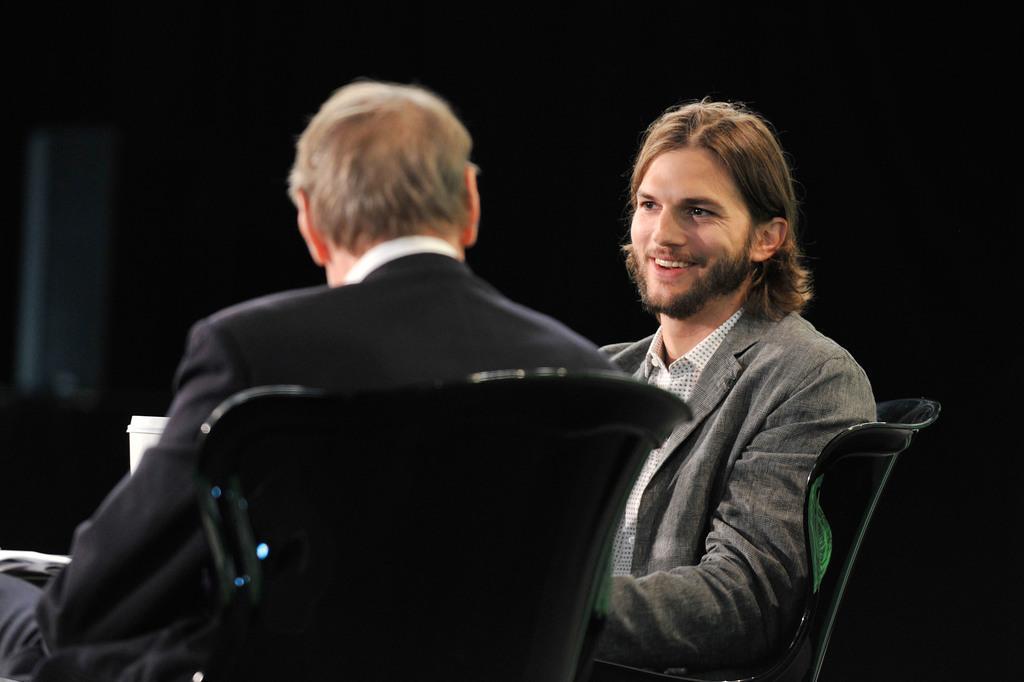How would you summarize this image in a sentence or two? In this image, I can see two persons are sitting on the chairs and one person is holding a paper in hand. In the background, I can see a dark color. This picture might be taken in a hall. 